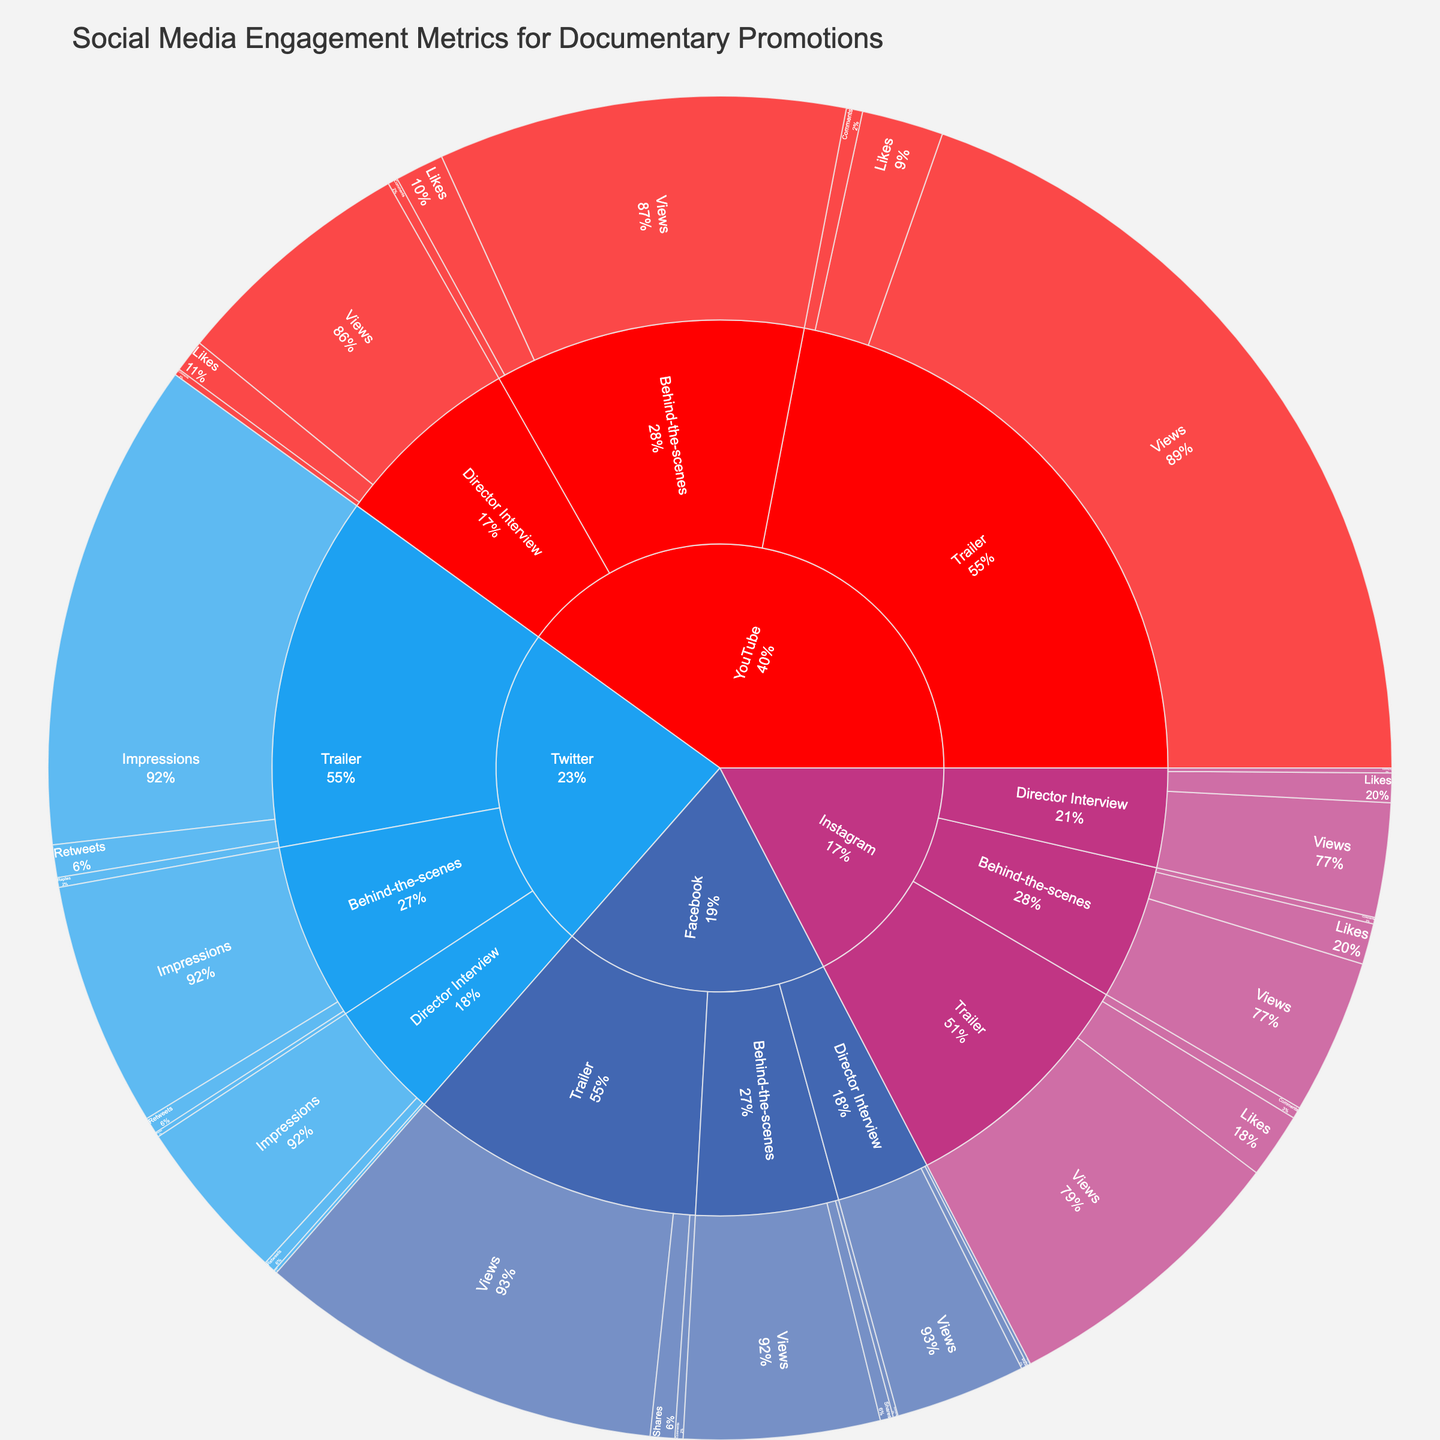How many platforms are represented in the sunburst plot? By observing the top-level hierarchy of the sunburst plot, we see four distinct sections, each representing a different social media platform.
Answer: 4 Which social media platform has the highest engagement for trailers? By examining the sections within the 'Trailer' content type, YouTube shows the largest values for its engagement metrics (Views, Likes, and Comments).
Answer: YouTube What is the combined number of shares for trailers across all platforms? We add the values for shares in the Trailer content type: Facebook (15000 shares) + Instagram (not applicable) + Twitter (not applicable) + YouTube (not applicable). Only Facebook tracks shares for trailers here.
Answer: 15000 Which content type on Facebook has the highest number of comments? By looking under each content type within Facebook, the 'Trailer' content type shows the highest number of comments at 5000.
Answer: Trailer How do the total views for director interviews compare between YouTube and Facebook? By checking the values for director interviews under both platforms: YouTube has 150,000 views while Facebook has 80,000 views. Hence, YouTube has more views for director interviews.
Answer: YouTube What's the total number of views for trailers across all platforms? Adding the views for trailers from Facebook (250000), Instagram (180000), and YouTube (500000). Twitter does not have views listed, it uses impressions instead. Total Views = 250000 + 180000 + 500000 = 930000.
Answer: 930000 Which social media platform has the fewest likes for behind-the-scenes content? By looking at Instagram and YouTube as they have likes for behind-the-scenes content: Instagram (25000 likes) and YouTube (30000 likes). Therefore, Instagram has the fewer likes for behind-the-scenes content.
Answer: Instagram Are there more retweets or replies for trailers on Twitter? By comparing values under 'Trailer' for Twitter: Retweets are 20,000 and Replies are 6,000. Therefore, there are more retweets than replies.
Answer: Retweets What percent of YouTube's total engagement for director interviews are likes? Total engagement for YouTube's director interviews is the sum of Views (150000), Likes (20000), and Comments (4000). Total = 150000 + 20000 + 4000 = 174000. Likes are 20000. Thus, the percentage = (20000/174000) * 100 ≈ 11.49%.
Answer: 11.49% 